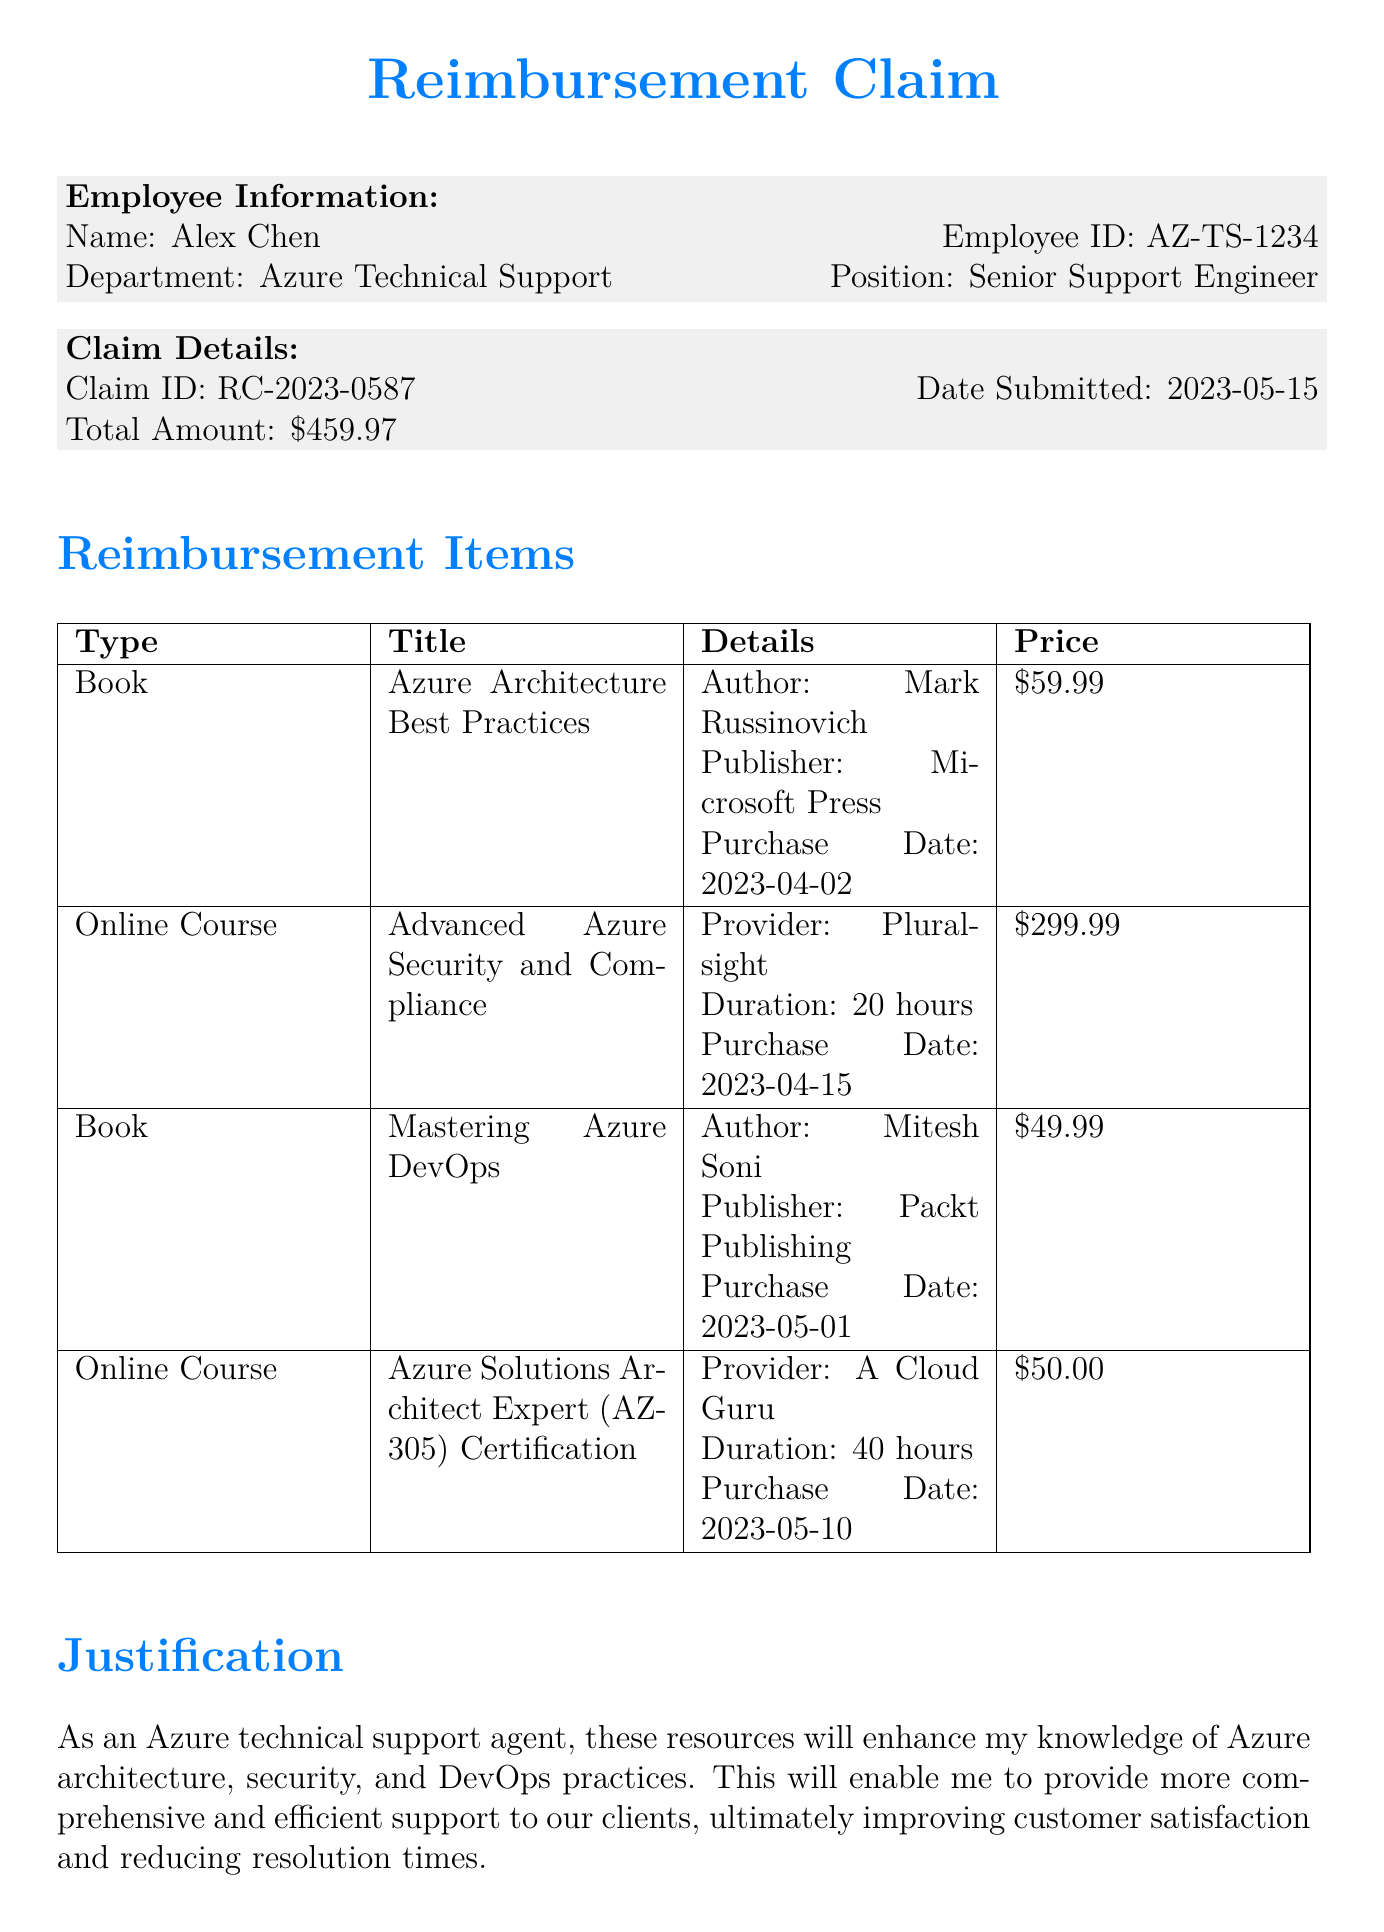What is the employee's name? The employee's name is stated in the Employee Information section of the document.
Answer: Alex Chen What is the claim ID? The claim ID is provided in the Claim Details section of the document.
Answer: RC-2023-0587 What is the total amount of the reimbursement claim? The total amount can be found in the Claim Details section, indicating the total expenses reported.
Answer: $459.97 How many hours is the "Advanced Azure Security and Compliance" online course? The duration of the course is specified in the Items section under that particular item.
Answer: 20 hours What is the purchase date of "Mastering Azure DevOps"? The purchase date is provided in the Items section for this specific book.
Answer: 2023-05-01 What is the approval status of the claim? The approval status of the claims is detailed in the Approval Chain section of the document.
Answer: Pending What is the reimbursement limit according to company policies? The reimbursement limit is indicated in the Company Policies section of the document.
Answer: $500.00 What types of resources are eligible for reimbursement? Eligible resources are listed in the Company Policies section of the document.
Answer: Books, Online Courses, Certification Exams What payment method is used for the reimbursement? The payment method is stated in the Payment Details section of the document.
Answer: Direct Deposit 